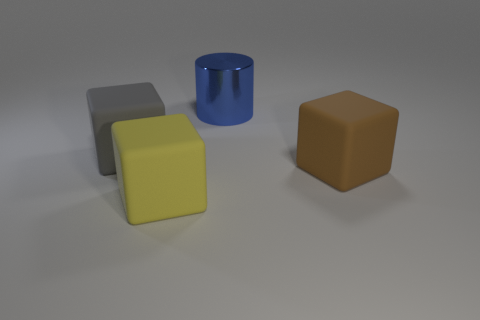How does the lighting in this image affect the mood or appearance? The soft, diffused lighting creates a calm atmosphere and allows the shapes and colors of the objects to be easily discernible, highlighting their form and material properties without harsh shadows. 